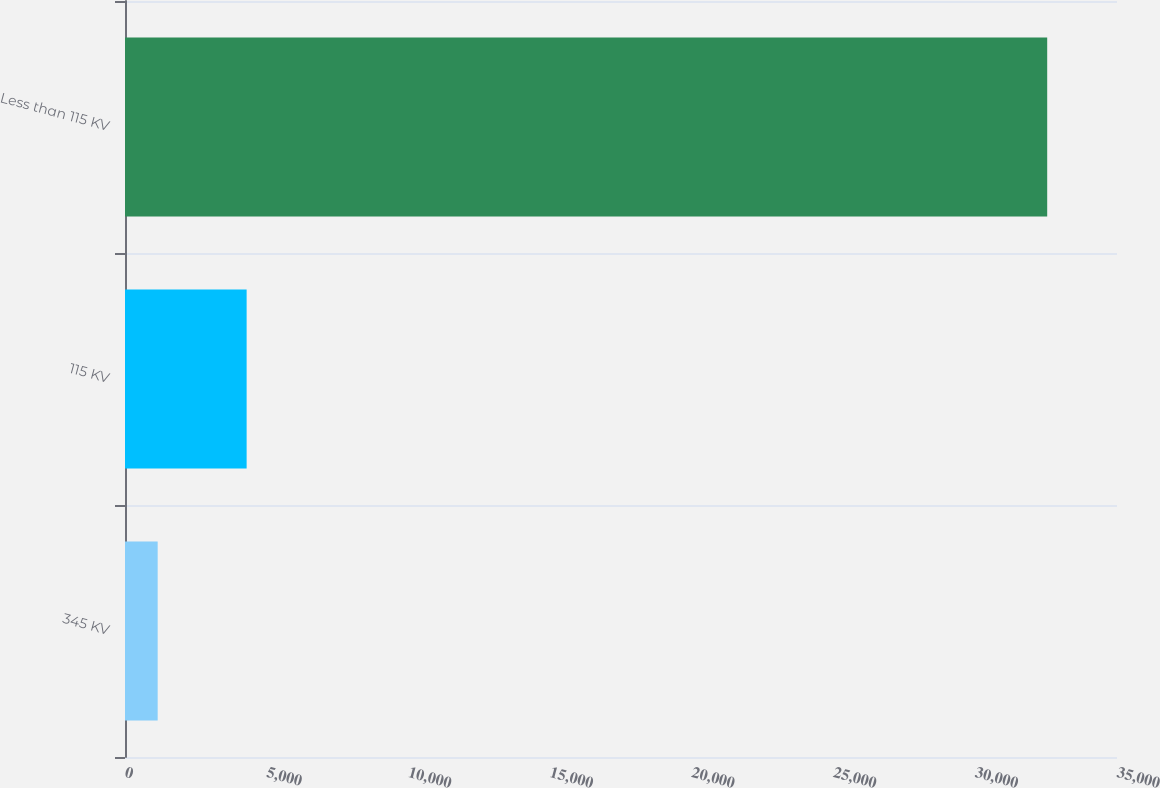<chart> <loc_0><loc_0><loc_500><loc_500><bar_chart><fcel>345 KV<fcel>115 KV<fcel>Less than 115 KV<nl><fcel>1153<fcel>4291.4<fcel>32537<nl></chart> 